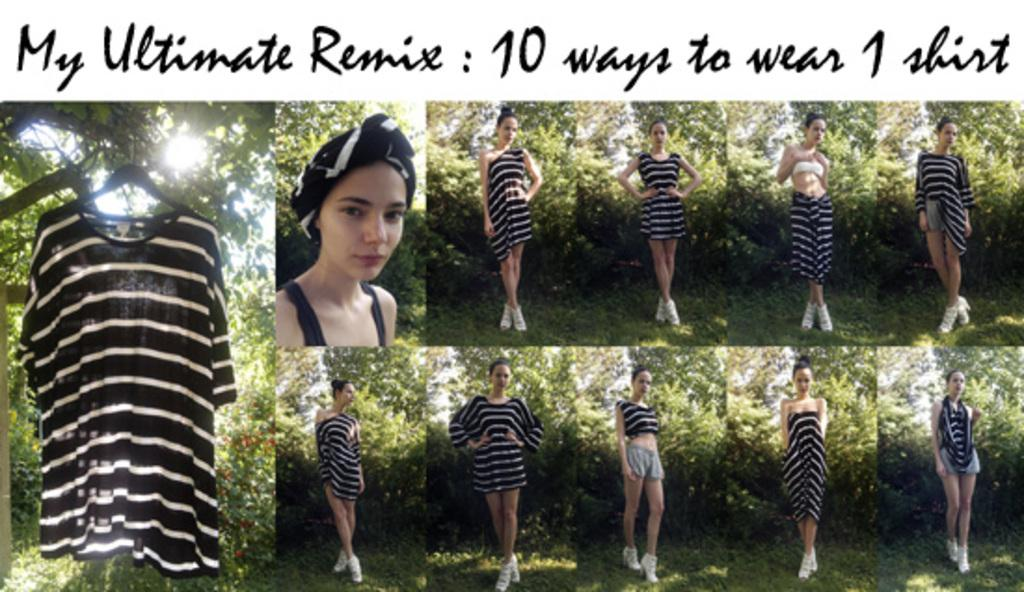What type of artwork is depicted in the image? The image is a collage. What subject matter is featured in the collage? The collage contains pictures of a girl. What can be seen in the background of the collage? There are trees in the background of the image. Where is the text located in the image? The text is at the top of the image. How does the girl attempt to clear her throat in the image? There is no indication in the image that the girl is attempting to clear her throat. Is the girl wearing skates in the image? There is no mention of skates or any other footwear in the image; the focus is on the girl's pictures in the collage. 